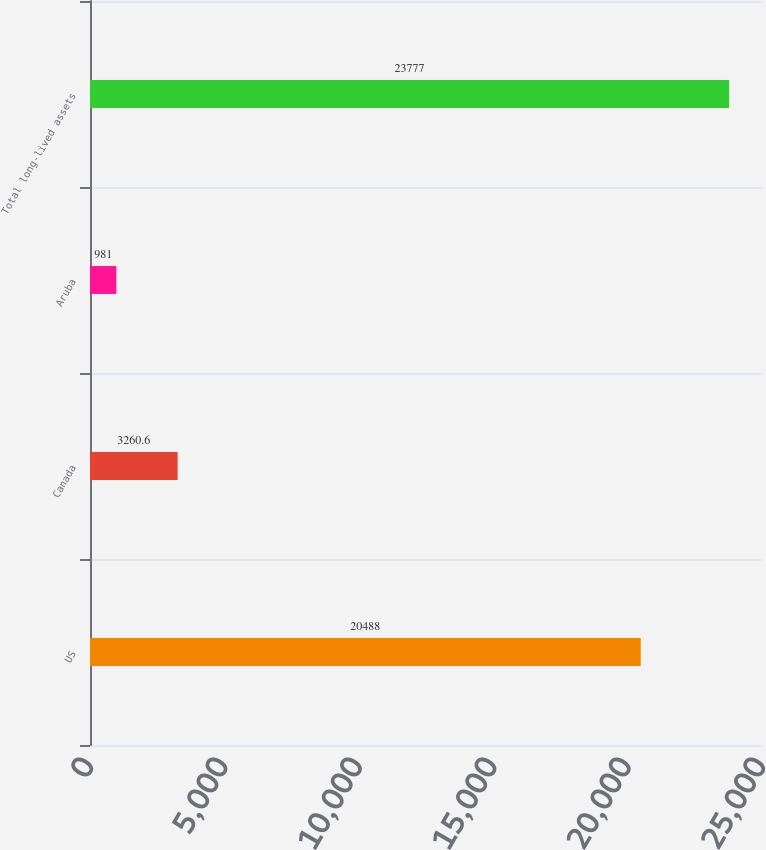Convert chart. <chart><loc_0><loc_0><loc_500><loc_500><bar_chart><fcel>US<fcel>Canada<fcel>Aruba<fcel>Total long-lived assets<nl><fcel>20488<fcel>3260.6<fcel>981<fcel>23777<nl></chart> 